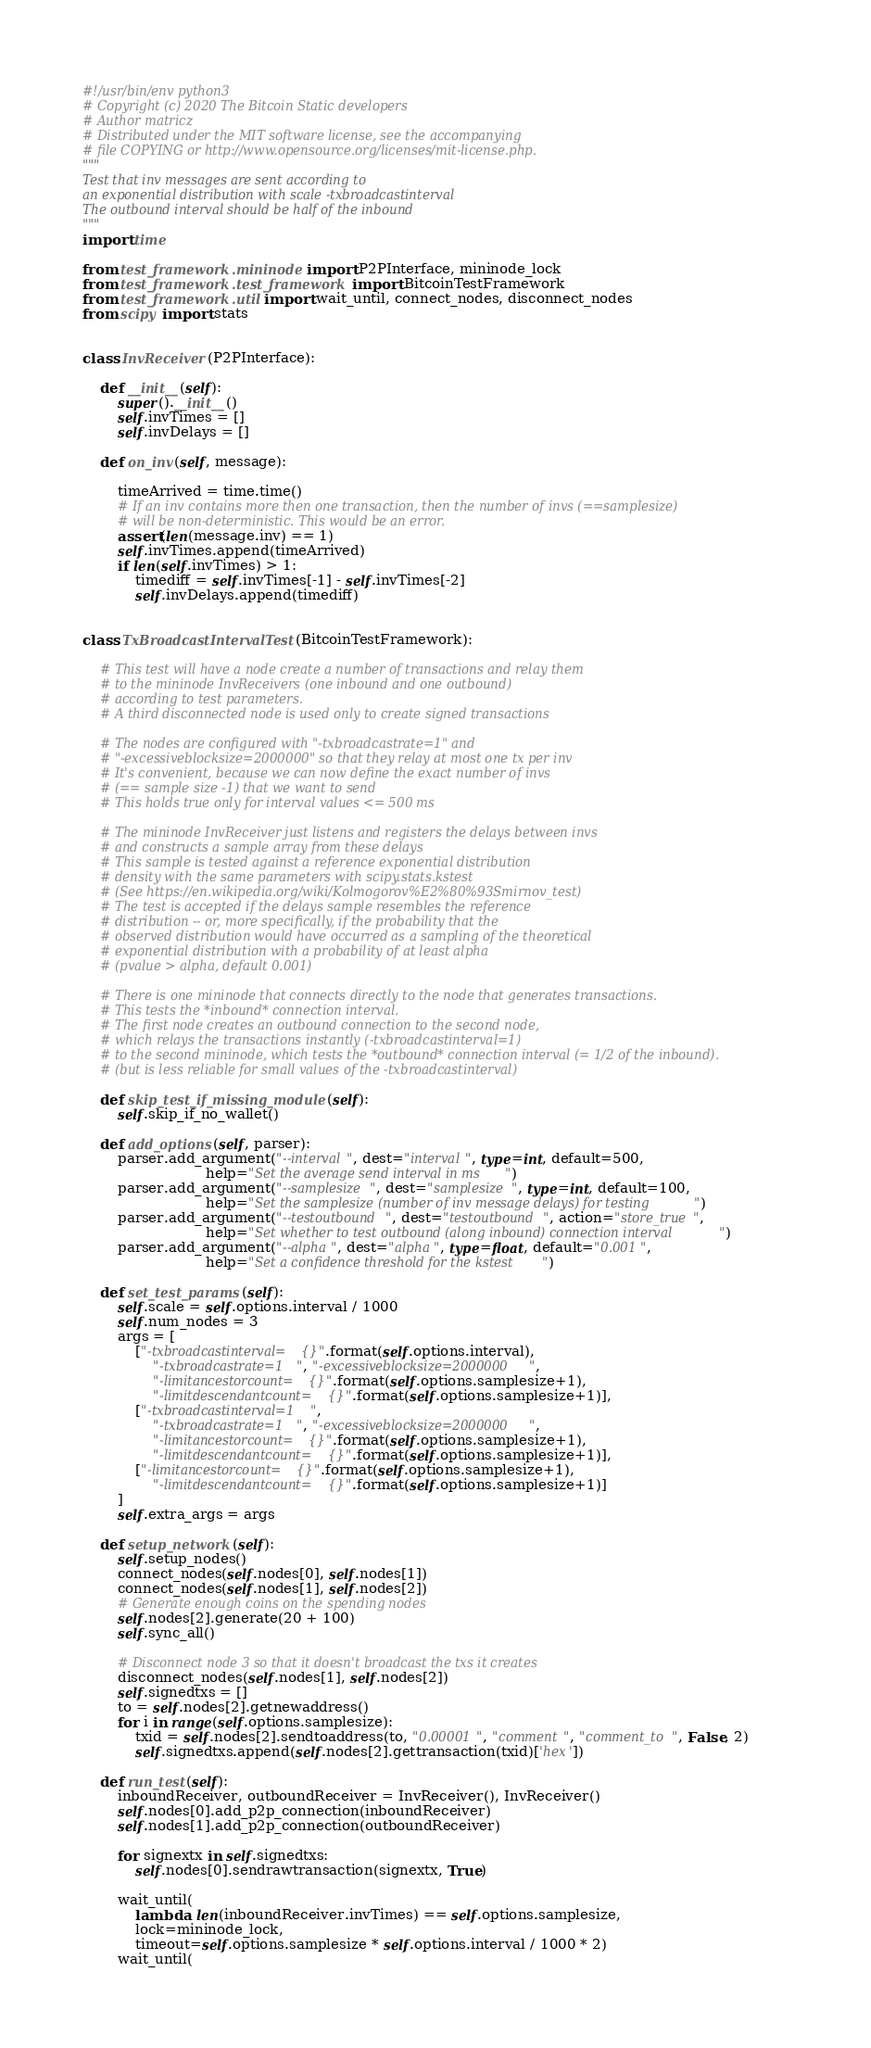Convert code to text. <code><loc_0><loc_0><loc_500><loc_500><_Python_>#!/usr/bin/env python3
# Copyright (c) 2020 The Bitcoin Static developers
# Author matricz
# Distributed under the MIT software license, see the accompanying
# file COPYING or http://www.opensource.org/licenses/mit-license.php.
"""
Test that inv messages are sent according to
an exponential distribution with scale -txbroadcastinterval
The outbound interval should be half of the inbound
"""
import time

from test_framework.mininode import P2PInterface, mininode_lock
from test_framework.test_framework import BitcoinTestFramework
from test_framework.util import wait_until, connect_nodes, disconnect_nodes
from scipy import stats


class InvReceiver(P2PInterface):

    def __init__(self):
        super().__init__()
        self.invTimes = []
        self.invDelays = []

    def on_inv(self, message):

        timeArrived = time.time()
        # If an inv contains more then one transaction, then the number of invs (==samplesize)
        # will be non-deterministic. This would be an error.
        assert(len(message.inv) == 1)
        self.invTimes.append(timeArrived)
        if len(self.invTimes) > 1:
            timediff = self.invTimes[-1] - self.invTimes[-2]
            self.invDelays.append(timediff)


class TxBroadcastIntervalTest(BitcoinTestFramework):

    # This test will have a node create a number of transactions and relay them
    # to the mininode InvReceivers (one inbound and one outbound)
    # according to test parameters.
    # A third disconnected node is used only to create signed transactions

    # The nodes are configured with "-txbroadcastrate=1" and
    # "-excessiveblocksize=2000000" so that they relay at most one tx per inv
    # It's convenient, because we can now define the exact number of invs
    # (== sample size -1) that we want to send
    # This holds true only for interval values <= 500 ms

    # The mininode InvReceiver just listens and registers the delays between invs
    # and constructs a sample array from these delays
    # This sample is tested against a reference exponential distribution
    # density with the same parameters with scipy.stats.kstest
    # (See https://en.wikipedia.org/wiki/Kolmogorov%E2%80%93Smirnov_test)
    # The test is accepted if the delays sample resembles the reference
    # distribution -- or, more specifically, if the probability that the
    # observed distribution would have occurred as a sampling of the theoretical
    # exponential distribution with a probability of at least alpha
    # (pvalue > alpha, default 0.001)

    # There is one mininode that connects directly to the node that generates transactions.
    # This tests the *inbound* connection interval.
    # The first node creates an outbound connection to the second node,
    # which relays the transactions instantly (-txbroadcastinterval=1)
    # to the second mininode, which tests the *outbound* connection interval (= 1/2 of the inbound).
    # (but is less reliable for small values of the -txbroadcastinterval)

    def skip_test_if_missing_module(self):
        self.skip_if_no_wallet()

    def add_options(self, parser):
        parser.add_argument("--interval", dest="interval", type=int, default=500,
                            help="Set the average send interval in ms")
        parser.add_argument("--samplesize", dest="samplesize", type=int, default=100,
                            help="Set the samplesize (number of inv message delays) for testing")
        parser.add_argument("--testoutbound", dest="testoutbound", action="store_true",
                            help="Set whether to test outbound (along inbound) connection interval")
        parser.add_argument("--alpha", dest="alpha", type=float, default="0.001",
                            help="Set a confidence threshold for the kstest")

    def set_test_params(self):
        self.scale = self.options.interval / 1000
        self.num_nodes = 3
        args = [
            ["-txbroadcastinterval={}".format(self.options.interval),
                "-txbroadcastrate=1", "-excessiveblocksize=2000000",
                "-limitancestorcount={}".format(self.options.samplesize+1),
                "-limitdescendantcount={}".format(self.options.samplesize+1)],
            ["-txbroadcastinterval=1",
                "-txbroadcastrate=1", "-excessiveblocksize=2000000",
                "-limitancestorcount={}".format(self.options.samplesize+1),
                "-limitdescendantcount={}".format(self.options.samplesize+1)],
            ["-limitancestorcount={}".format(self.options.samplesize+1),
                "-limitdescendantcount={}".format(self.options.samplesize+1)]
        ]
        self.extra_args = args

    def setup_network(self):
        self.setup_nodes()
        connect_nodes(self.nodes[0], self.nodes[1])
        connect_nodes(self.nodes[1], self.nodes[2])
        # Generate enough coins on the spending nodes
        self.nodes[2].generate(20 + 100)
        self.sync_all()

        # Disconnect node 3 so that it doesn't broadcast the txs it creates
        disconnect_nodes(self.nodes[1], self.nodes[2])
        self.signedtxs = []
        to = self.nodes[2].getnewaddress()
        for i in range(self.options.samplesize):
            txid = self.nodes[2].sendtoaddress(to, "0.00001", "comment", "comment_to", False, 2)
            self.signedtxs.append(self.nodes[2].gettransaction(txid)['hex'])

    def run_test(self):
        inboundReceiver, outboundReceiver = InvReceiver(), InvReceiver()
        self.nodes[0].add_p2p_connection(inboundReceiver)
        self.nodes[1].add_p2p_connection(outboundReceiver)

        for signextx in self.signedtxs:
            self.nodes[0].sendrawtransaction(signextx, True)

        wait_until(
            lambda: len(inboundReceiver.invTimes) == self.options.samplesize,
            lock=mininode_lock,
            timeout=self.options.samplesize * self.options.interval / 1000 * 2)
        wait_until(</code> 